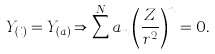Convert formula to latex. <formula><loc_0><loc_0><loc_500><loc_500>Y _ { ( i ) } = Y _ { ( a ) } \Rightarrow \sum ^ { N } a _ { n } \left ( \frac { Z } { r ^ { 2 } } \right ) ^ { n } = 0 .</formula> 